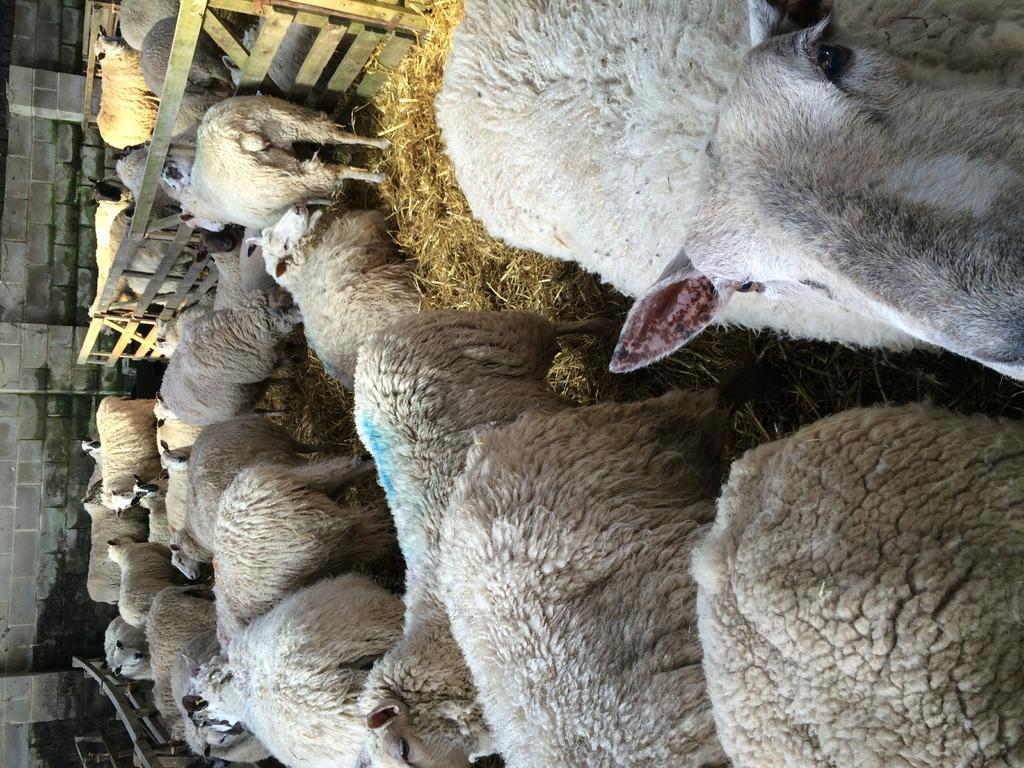Could you give a brief overview of what you see in this image? In this image I can see many animals which are in white and brown color. I can also see the dried grass in-between these animals. To the side I can see the railing. To the left I can see the wall. 